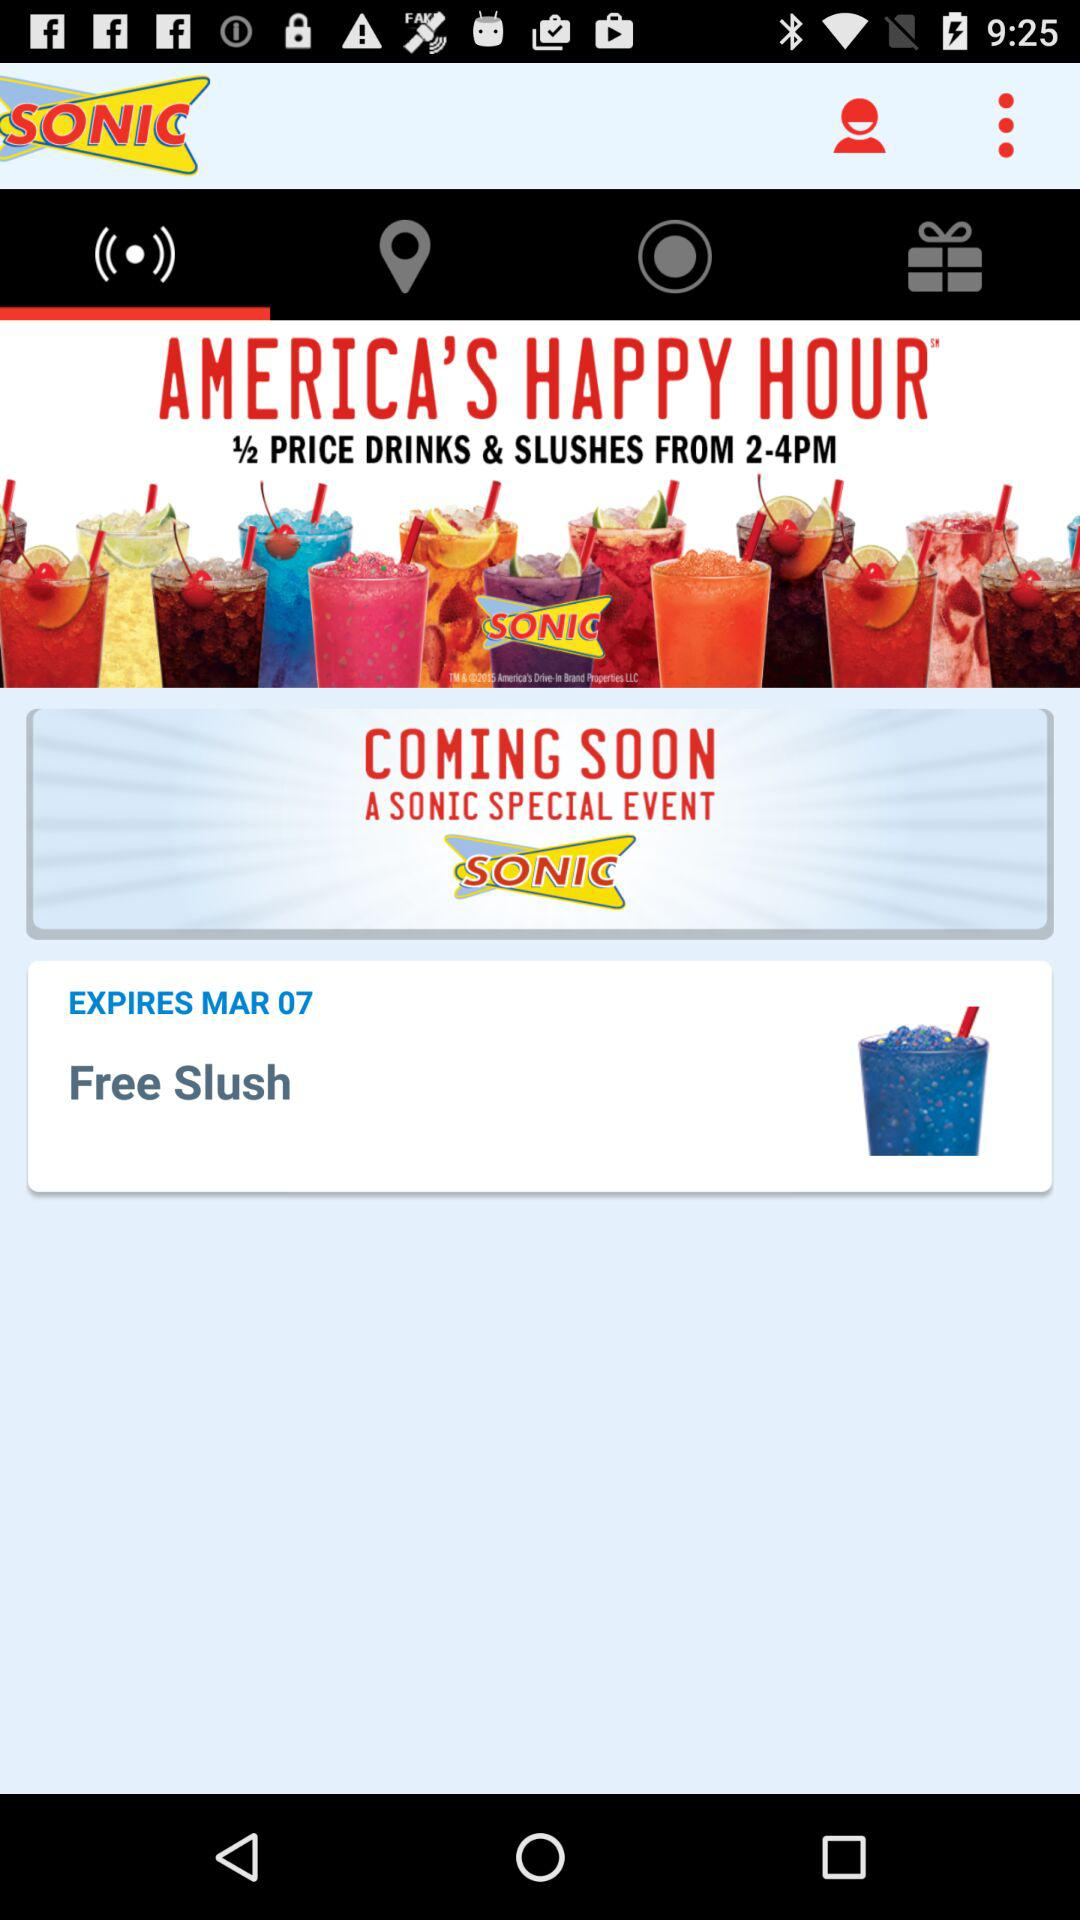On what date will "Free Slush" expire? The "Free Slush" will expire on March 07. 